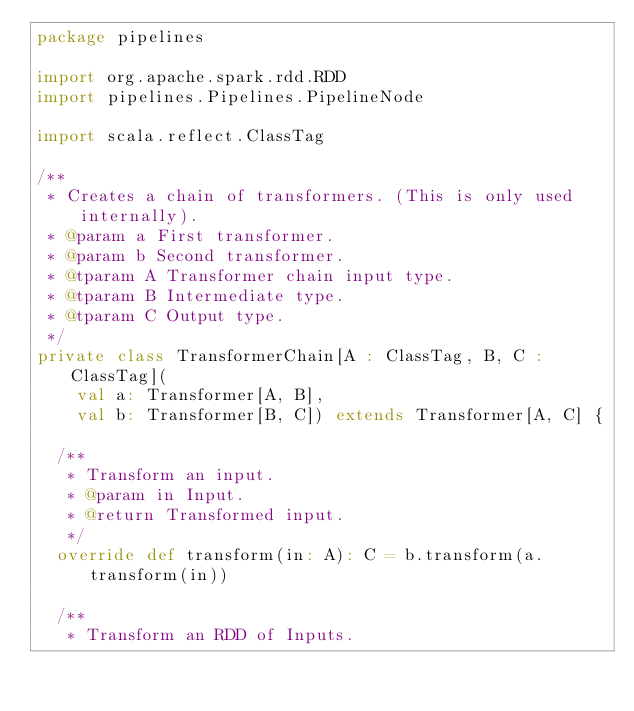Convert code to text. <code><loc_0><loc_0><loc_500><loc_500><_Scala_>package pipelines

import org.apache.spark.rdd.RDD
import pipelines.Pipelines.PipelineNode

import scala.reflect.ClassTag

/**
 * Creates a chain of transformers. (This is only used internally).
 * @param a First transformer.
 * @param b Second transformer.
 * @tparam A Transformer chain input type.
 * @tparam B Intermediate type.
 * @tparam C Output type.
 */
private class TransformerChain[A : ClassTag, B, C : ClassTag](
    val a: Transformer[A, B],
    val b: Transformer[B, C]) extends Transformer[A, C] {

  /**
   * Transform an input.
   * @param in Input.
   * @return Transformed input.
   */
  override def transform(in: A): C = b.transform(a.transform(in))

  /**
   * Transform an RDD of Inputs.</code> 